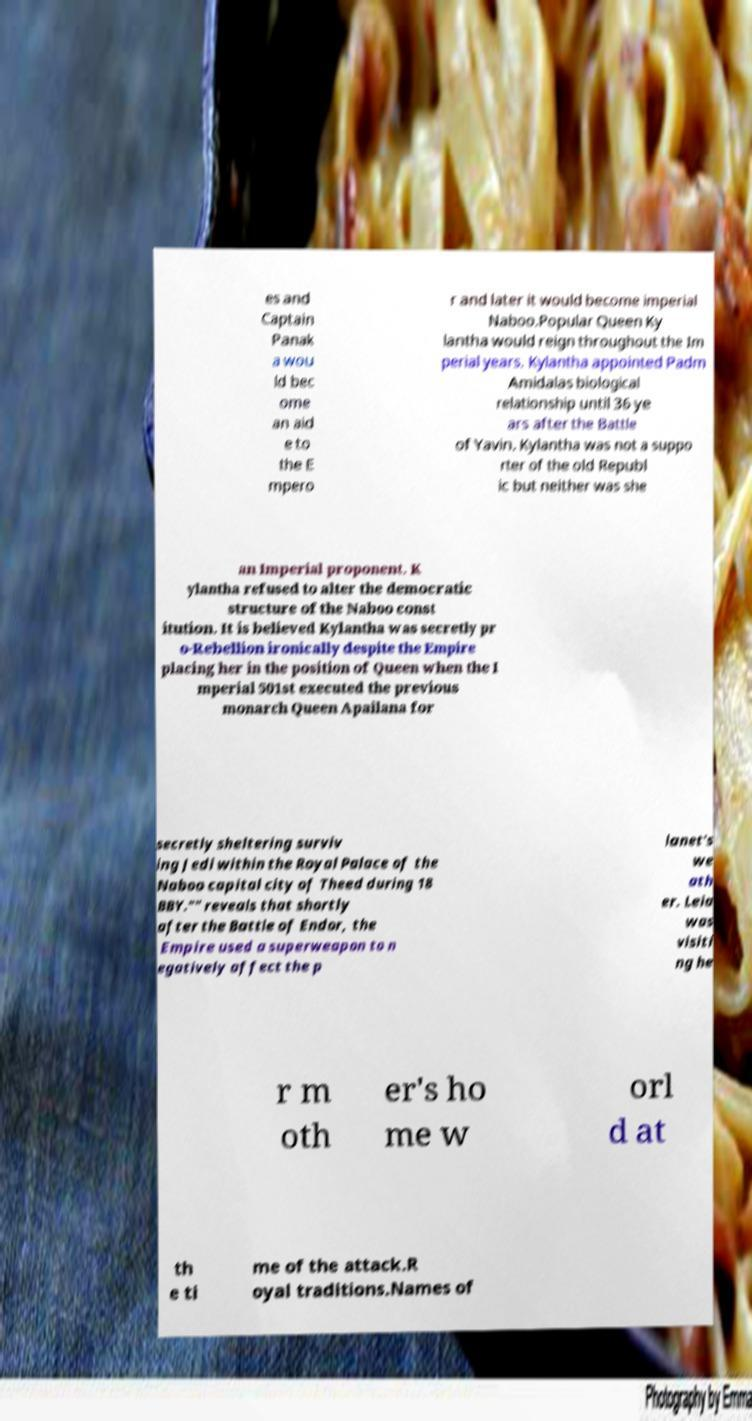For documentation purposes, I need the text within this image transcribed. Could you provide that? es and Captain Panak a wou ld bec ome an aid e to the E mpero r and later it would become imperial Naboo.Popular Queen Ky lantha would reign throughout the Im perial years. Kylantha appointed Padm Amidalas biological relationship until 36 ye ars after the Battle of Yavin. Kylantha was not a suppo rter of the old Republ ic but neither was she an Imperial proponent. K ylantha refused to alter the democratic structure of the Naboo const itution. It is believed Kylantha was secretly pr o-Rebellion ironically despite the Empire placing her in the position of Queen when the I mperial 501st executed the previous monarch Queen Apailana for secretly sheltering surviv ing Jedi within the Royal Palace of the Naboo capital city of Theed during 18 BBY."" reveals that shortly after the Battle of Endor, the Empire used a superweapon to n egatively affect the p lanet's we ath er. Leia was visiti ng he r m oth er's ho me w orl d at th e ti me of the attack.R oyal traditions.Names of 